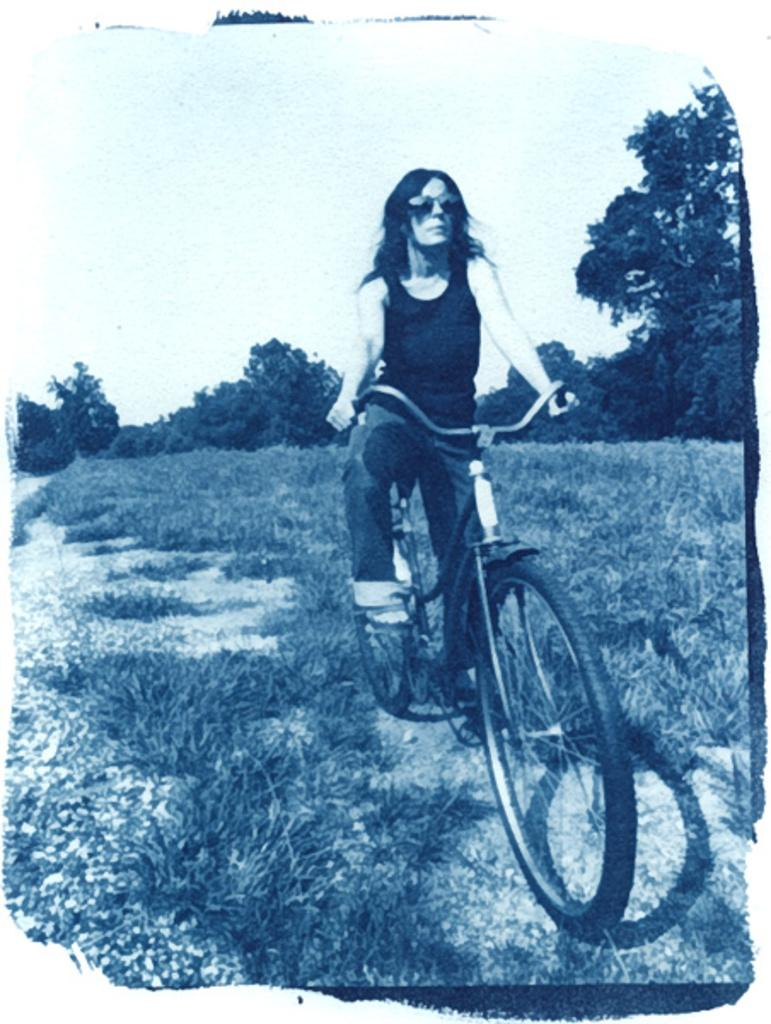What is the main subject of the image? The main subject of the image is a woman. What is the woman doing in the image? The woman is riding a bicycle in the image. What can be seen in the background of the image? There are green color trees and the sky visible in the background of the image. How is the sky described in the image? The sky is described as white color in the image. What type of pancake is the woman holding while riding the bicycle? There is no pancake present in the image; the woman is riding a bicycle without holding any pancake. 